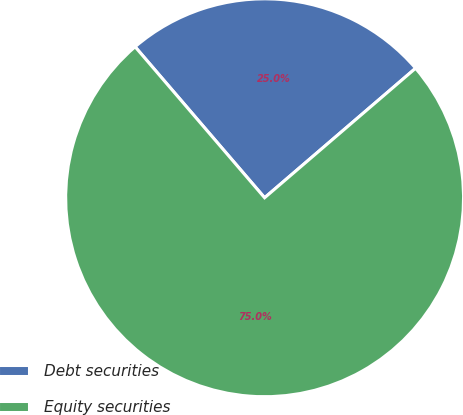Convert chart. <chart><loc_0><loc_0><loc_500><loc_500><pie_chart><fcel>Debt securities<fcel>Equity securities<nl><fcel>25.0%<fcel>75.0%<nl></chart> 